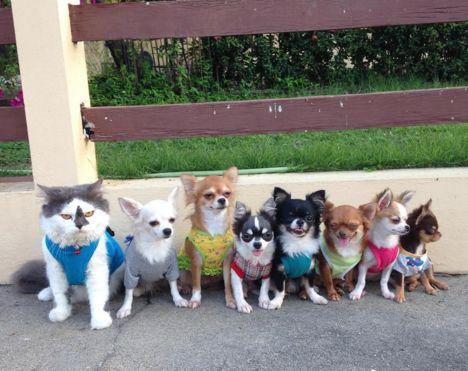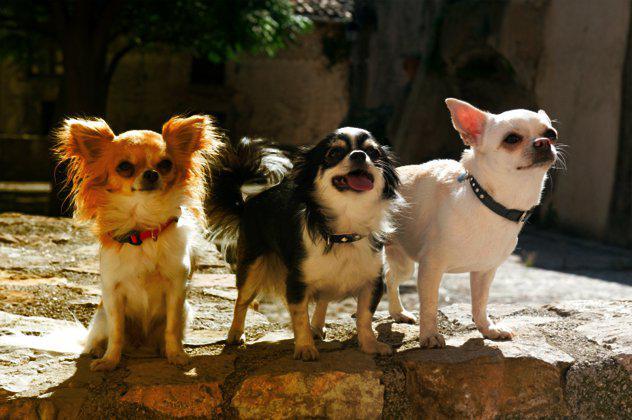The first image is the image on the left, the second image is the image on the right. For the images displayed, is the sentence "there is a row of animals dressed in clothes" factually correct? Answer yes or no. Yes. The first image is the image on the left, the second image is the image on the right. Analyze the images presented: Is the assertion "One image contains exactly three dogs." valid? Answer yes or no. Yes. 